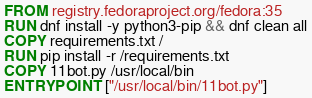Convert code to text. <code><loc_0><loc_0><loc_500><loc_500><_Dockerfile_>FROM registry.fedoraproject.org/fedora:35
RUN dnf install -y python3-pip && dnf clean all
COPY requirements.txt /
RUN pip install -r /requirements.txt
COPY 11bot.py /usr/local/bin
ENTRYPOINT ["/usr/local/bin/11bot.py"]
</code> 